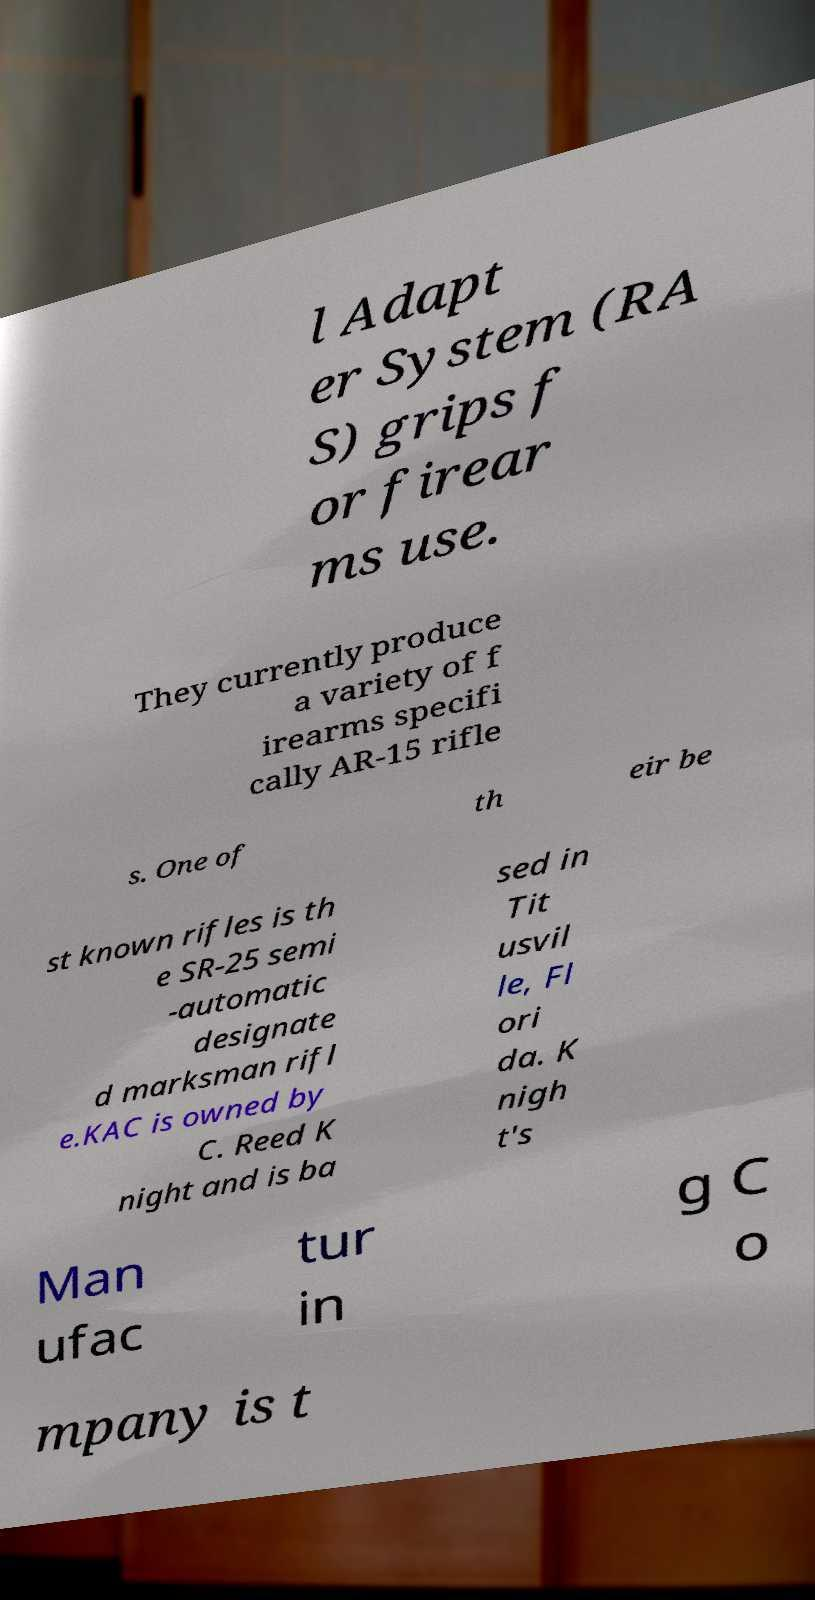Can you accurately transcribe the text from the provided image for me? l Adapt er System (RA S) grips f or firear ms use. They currently produce a variety of f irearms specifi cally AR-15 rifle s. One of th eir be st known rifles is th e SR-25 semi -automatic designate d marksman rifl e.KAC is owned by C. Reed K night and is ba sed in Tit usvil le, Fl ori da. K nigh t's Man ufac tur in g C o mpany is t 